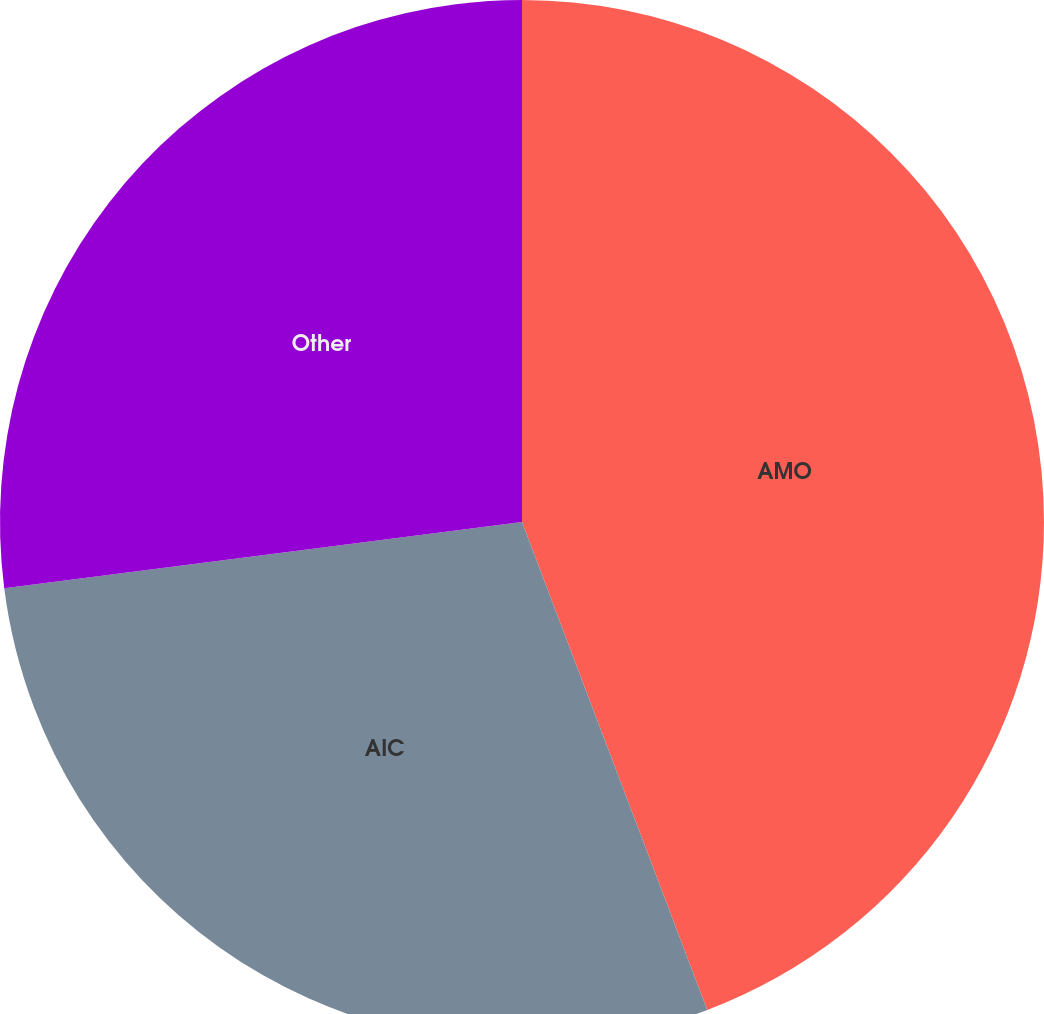Convert chart. <chart><loc_0><loc_0><loc_500><loc_500><pie_chart><fcel>AMO<fcel>AIC<fcel>Other<nl><fcel>44.23%<fcel>28.75%<fcel>27.03%<nl></chart> 